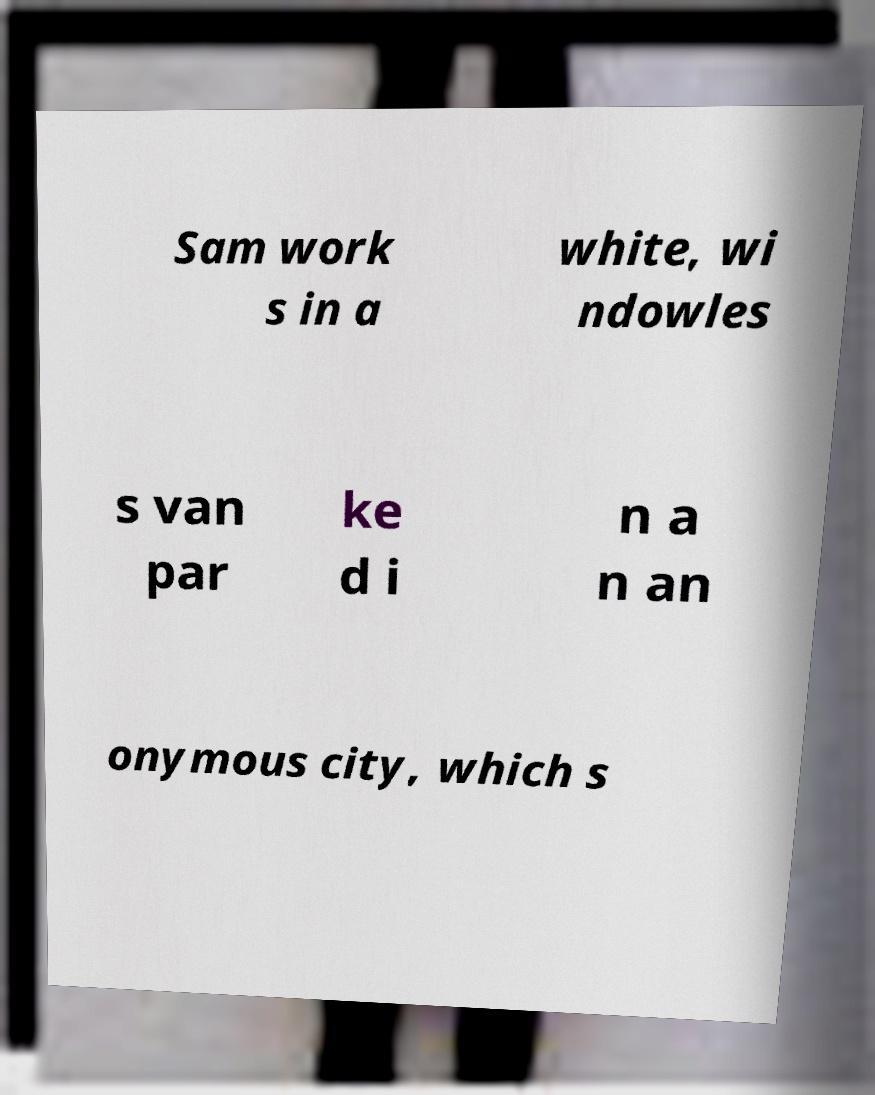Please identify and transcribe the text found in this image. Sam work s in a white, wi ndowles s van par ke d i n a n an onymous city, which s 